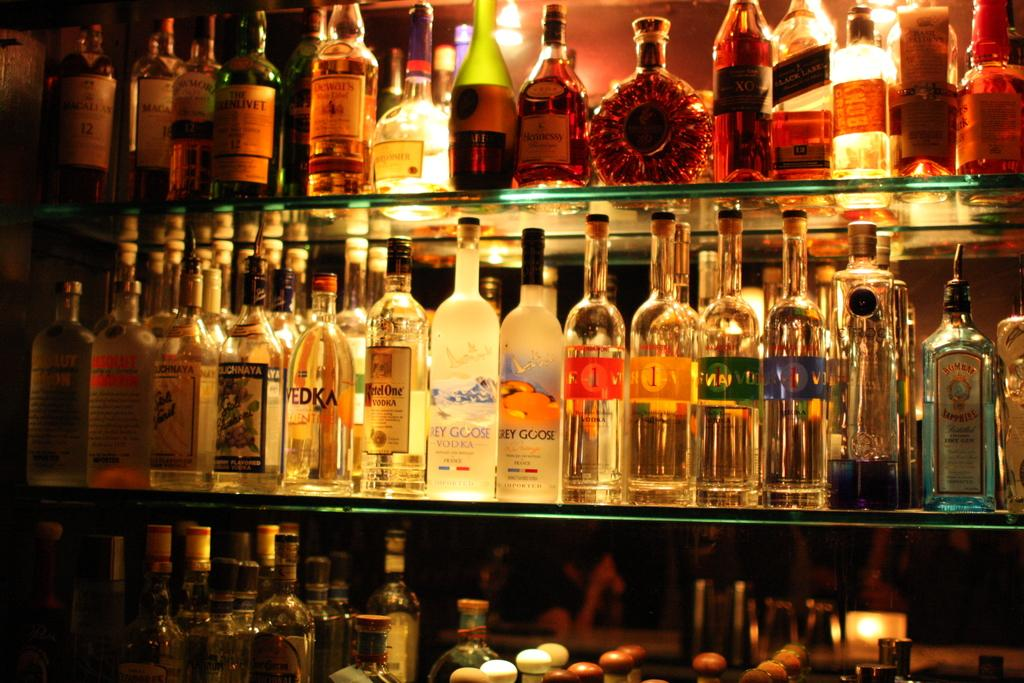Provide a one-sentence caption for the provided image. bottles of liquor lined up on glass bar shelves include Ketel One Vodka. 